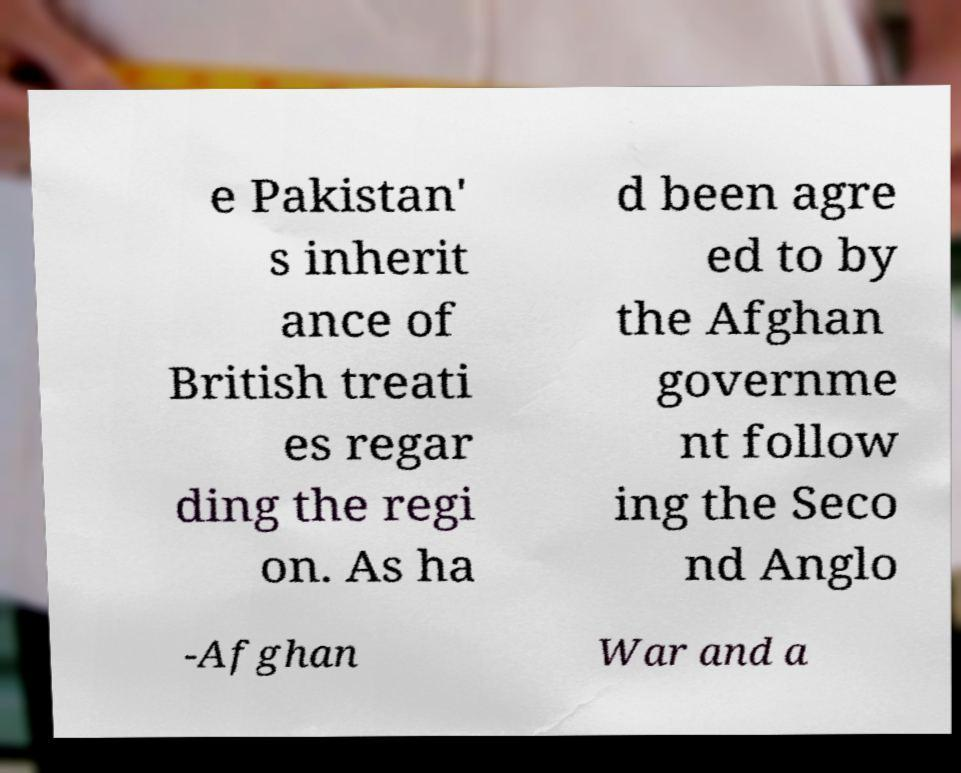For documentation purposes, I need the text within this image transcribed. Could you provide that? e Pakistan' s inherit ance of British treati es regar ding the regi on. As ha d been agre ed to by the Afghan governme nt follow ing the Seco nd Anglo -Afghan War and a 